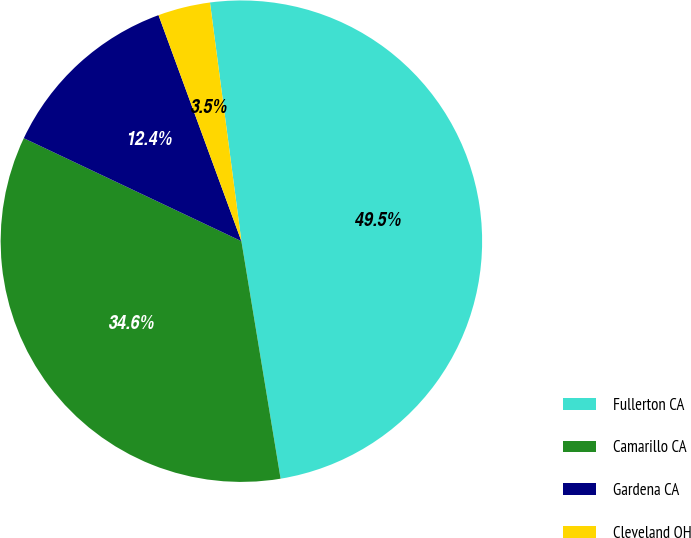<chart> <loc_0><loc_0><loc_500><loc_500><pie_chart><fcel>Fullerton CA<fcel>Camarillo CA<fcel>Gardena CA<fcel>Cleveland OH<nl><fcel>49.48%<fcel>34.64%<fcel>12.37%<fcel>3.51%<nl></chart> 